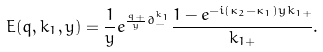Convert formula to latex. <formula><loc_0><loc_0><loc_500><loc_500>E ( q , k _ { 1 } , y ) = \frac { 1 } { y } e ^ { \frac { q _ { + } } { y } \partial _ { - } ^ { k _ { 1 } } } \frac { 1 - e ^ { - i ( \kappa _ { 2 } - \kappa _ { 1 } ) y k _ { 1 + } } } { k _ { 1 + } } .</formula> 